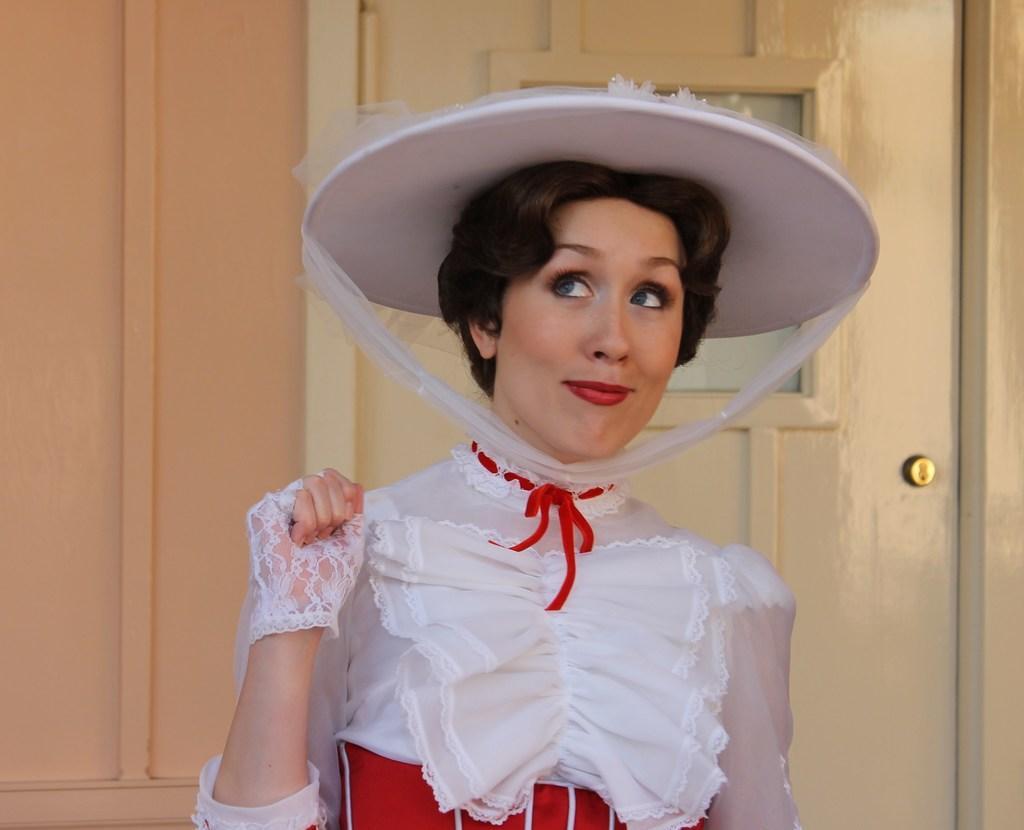Could you give a brief overview of what you see in this image? In this image we can see a lady person wearing white and red color dress also wearing white color hat smiling and in the background of the image there is a wall and door. 